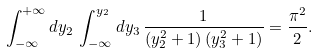<formula> <loc_0><loc_0><loc_500><loc_500>\int _ { - \infty } ^ { + \infty } d y _ { 2 } \, \int _ { - \infty } ^ { y _ { 2 } } d y _ { 3 } \, \frac { 1 } { \left ( y _ { 2 } ^ { 2 } + 1 \right ) \left ( y _ { 3 } ^ { 2 } + 1 \right ) } = \frac { \pi ^ { 2 } } { 2 } .</formula> 